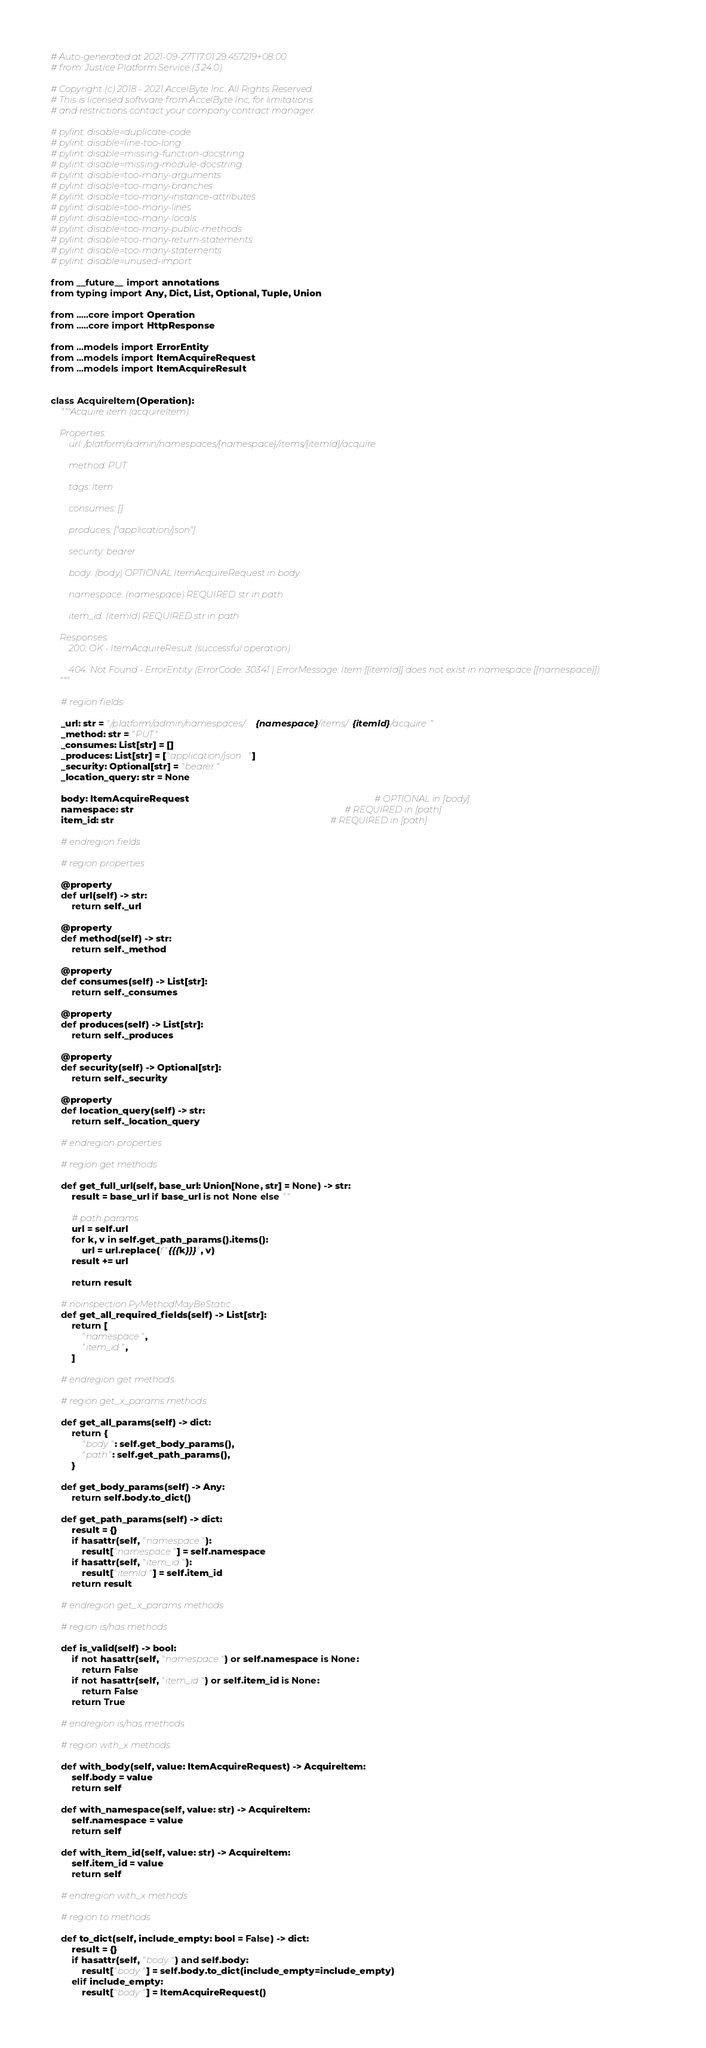Convert code to text. <code><loc_0><loc_0><loc_500><loc_500><_Python_># Auto-generated at 2021-09-27T17:01:29.457219+08:00
# from: Justice Platform Service (3.24.0)

# Copyright (c) 2018 - 2021 AccelByte Inc. All Rights Reserved.
# This is licensed software from AccelByte Inc, for limitations
# and restrictions contact your company contract manager.

# pylint: disable=duplicate-code
# pylint: disable=line-too-long
# pylint: disable=missing-function-docstring
# pylint: disable=missing-module-docstring
# pylint: disable=too-many-arguments
# pylint: disable=too-many-branches
# pylint: disable=too-many-instance-attributes
# pylint: disable=too-many-lines
# pylint: disable=too-many-locals
# pylint: disable=too-many-public-methods
# pylint: disable=too-many-return-statements
# pylint: disable=too-many-statements
# pylint: disable=unused-import

from __future__ import annotations
from typing import Any, Dict, List, Optional, Tuple, Union

from .....core import Operation
from .....core import HttpResponse

from ...models import ErrorEntity
from ...models import ItemAcquireRequest
from ...models import ItemAcquireResult


class AcquireItem(Operation):
    """Acquire item (acquireItem)

    Properties:
        url: /platform/admin/namespaces/{namespace}/items/{itemId}/acquire

        method: PUT

        tags: Item

        consumes: []

        produces: ["application/json"]

        security: bearer

        body: (body) OPTIONAL ItemAcquireRequest in body

        namespace: (namespace) REQUIRED str in path

        item_id: (itemId) REQUIRED str in path

    Responses:
        200: OK - ItemAcquireResult (successful operation)

        404: Not Found - ErrorEntity (ErrorCode: 30341 | ErrorMessage: Item [{itemId}] does not exist in namespace [{namespace}])
    """

    # region fields

    _url: str = "/platform/admin/namespaces/{namespace}/items/{itemId}/acquire"
    _method: str = "PUT"
    _consumes: List[str] = []
    _produces: List[str] = ["application/json"]
    _security: Optional[str] = "bearer"
    _location_query: str = None

    body: ItemAcquireRequest                                                                       # OPTIONAL in [body]
    namespace: str                                                                                 # REQUIRED in [path]
    item_id: str                                                                                   # REQUIRED in [path]

    # endregion fields

    # region properties

    @property
    def url(self) -> str:
        return self._url

    @property
    def method(self) -> str:
        return self._method

    @property
    def consumes(self) -> List[str]:
        return self._consumes

    @property
    def produces(self) -> List[str]:
        return self._produces

    @property
    def security(self) -> Optional[str]:
        return self._security

    @property
    def location_query(self) -> str:
        return self._location_query

    # endregion properties

    # region get methods

    def get_full_url(self, base_url: Union[None, str] = None) -> str:
        result = base_url if base_url is not None else ""

        # path params
        url = self.url
        for k, v in self.get_path_params().items():
            url = url.replace(f"{{{k}}}", v)
        result += url

        return result

    # noinspection PyMethodMayBeStatic
    def get_all_required_fields(self) -> List[str]:
        return [
            "namespace",
            "item_id",
        ]

    # endregion get methods

    # region get_x_params methods

    def get_all_params(self) -> dict:
        return {
            "body": self.get_body_params(),
            "path": self.get_path_params(),
        }

    def get_body_params(self) -> Any:
        return self.body.to_dict()

    def get_path_params(self) -> dict:
        result = {}
        if hasattr(self, "namespace"):
            result["namespace"] = self.namespace
        if hasattr(self, "item_id"):
            result["itemId"] = self.item_id
        return result

    # endregion get_x_params methods

    # region is/has methods

    def is_valid(self) -> bool:
        if not hasattr(self, "namespace") or self.namespace is None:
            return False
        if not hasattr(self, "item_id") or self.item_id is None:
            return False
        return True

    # endregion is/has methods

    # region with_x methods

    def with_body(self, value: ItemAcquireRequest) -> AcquireItem:
        self.body = value
        return self

    def with_namespace(self, value: str) -> AcquireItem:
        self.namespace = value
        return self

    def with_item_id(self, value: str) -> AcquireItem:
        self.item_id = value
        return self

    # endregion with_x methods

    # region to methods

    def to_dict(self, include_empty: bool = False) -> dict:
        result = {}
        if hasattr(self, "body") and self.body:
            result["body"] = self.body.to_dict(include_empty=include_empty)
        elif include_empty:
            result["body"] = ItemAcquireRequest()</code> 